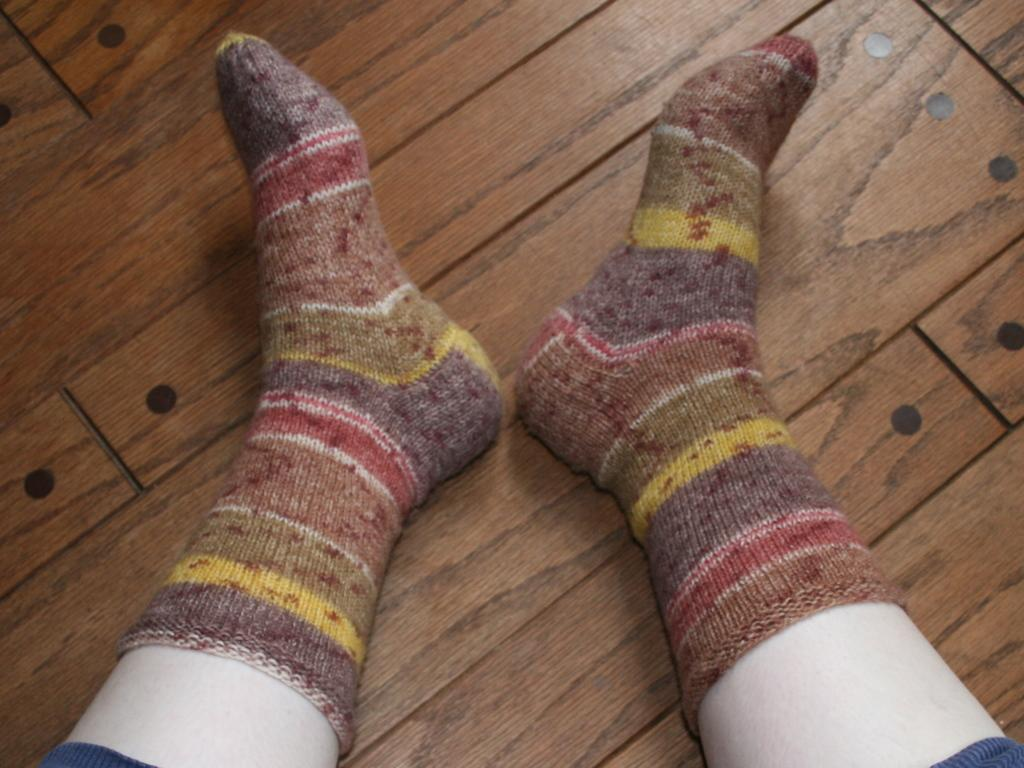What part of the body is visible in the image? There are legs visible in the image. Where are the legs located? The legs are on the floor. What type of plant is growing on the legs in the image? There is no plant growing on the legs in the image; only the legs are visible. 